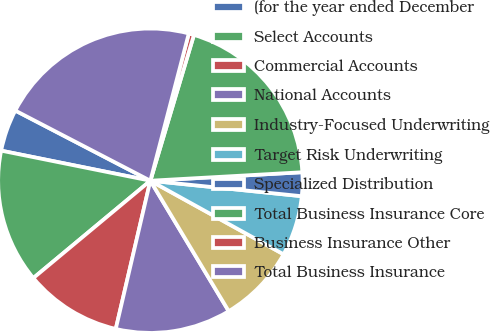Convert chart. <chart><loc_0><loc_0><loc_500><loc_500><pie_chart><fcel>(for the year ended December<fcel>Select Accounts<fcel>Commercial Accounts<fcel>National Accounts<fcel>Industry-Focused Underwriting<fcel>Target Risk Underwriting<fcel>Specialized Distribution<fcel>Total Business Insurance Core<fcel>Business Insurance Other<fcel>Total Business Insurance<nl><fcel>4.46%<fcel>14.21%<fcel>10.31%<fcel>12.26%<fcel>8.36%<fcel>6.41%<fcel>2.51%<fcel>19.49%<fcel>0.56%<fcel>21.44%<nl></chart> 